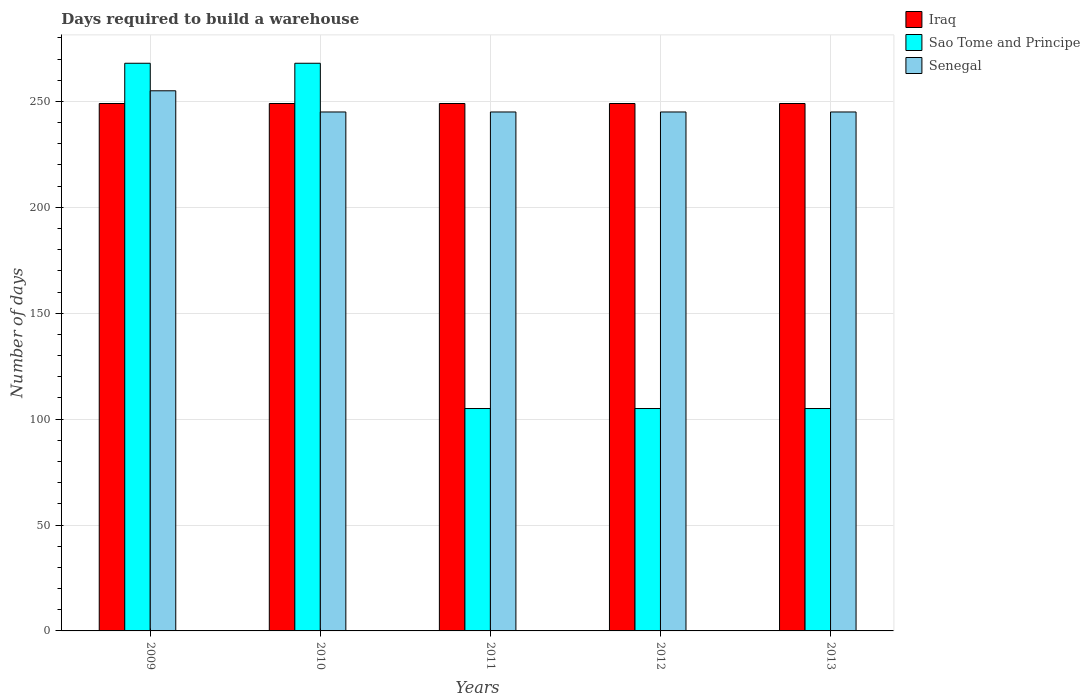How many groups of bars are there?
Provide a short and direct response. 5. Are the number of bars per tick equal to the number of legend labels?
Provide a succinct answer. Yes. How many bars are there on the 3rd tick from the right?
Give a very brief answer. 3. What is the label of the 5th group of bars from the left?
Ensure brevity in your answer.  2013. In how many cases, is the number of bars for a given year not equal to the number of legend labels?
Offer a terse response. 0. What is the days required to build a warehouse in in Iraq in 2009?
Give a very brief answer. 249. Across all years, what is the maximum days required to build a warehouse in in Iraq?
Offer a terse response. 249. Across all years, what is the minimum days required to build a warehouse in in Sao Tome and Principe?
Your answer should be very brief. 105. In which year was the days required to build a warehouse in in Senegal maximum?
Your answer should be compact. 2009. In which year was the days required to build a warehouse in in Senegal minimum?
Keep it short and to the point. 2010. What is the total days required to build a warehouse in in Sao Tome and Principe in the graph?
Offer a very short reply. 851. What is the difference between the days required to build a warehouse in in Senegal in 2009 and that in 2012?
Your answer should be very brief. 10. What is the difference between the days required to build a warehouse in in Sao Tome and Principe in 2011 and the days required to build a warehouse in in Iraq in 2010?
Provide a succinct answer. -144. What is the average days required to build a warehouse in in Iraq per year?
Provide a short and direct response. 249. In the year 2011, what is the difference between the days required to build a warehouse in in Sao Tome and Principe and days required to build a warehouse in in Senegal?
Provide a succinct answer. -140. In how many years, is the days required to build a warehouse in in Senegal greater than 240 days?
Provide a succinct answer. 5. What is the ratio of the days required to build a warehouse in in Sao Tome and Principe in 2010 to that in 2012?
Keep it short and to the point. 2.55. What is the difference between the highest and the second highest days required to build a warehouse in in Iraq?
Offer a terse response. 0. What is the difference between the highest and the lowest days required to build a warehouse in in Iraq?
Your answer should be very brief. 0. What does the 1st bar from the left in 2013 represents?
Provide a succinct answer. Iraq. What does the 2nd bar from the right in 2011 represents?
Keep it short and to the point. Sao Tome and Principe. Is it the case that in every year, the sum of the days required to build a warehouse in in Senegal and days required to build a warehouse in in Sao Tome and Principe is greater than the days required to build a warehouse in in Iraq?
Your answer should be compact. Yes. Are all the bars in the graph horizontal?
Your answer should be very brief. No. How many years are there in the graph?
Your answer should be compact. 5. What is the difference between two consecutive major ticks on the Y-axis?
Provide a short and direct response. 50. Does the graph contain any zero values?
Provide a short and direct response. No. How many legend labels are there?
Your response must be concise. 3. What is the title of the graph?
Offer a very short reply. Days required to build a warehouse. Does "American Samoa" appear as one of the legend labels in the graph?
Make the answer very short. No. What is the label or title of the Y-axis?
Keep it short and to the point. Number of days. What is the Number of days in Iraq in 2009?
Your response must be concise. 249. What is the Number of days in Sao Tome and Principe in 2009?
Give a very brief answer. 268. What is the Number of days in Senegal in 2009?
Make the answer very short. 255. What is the Number of days in Iraq in 2010?
Your response must be concise. 249. What is the Number of days of Sao Tome and Principe in 2010?
Offer a very short reply. 268. What is the Number of days of Senegal in 2010?
Your answer should be compact. 245. What is the Number of days of Iraq in 2011?
Keep it short and to the point. 249. What is the Number of days in Sao Tome and Principe in 2011?
Offer a very short reply. 105. What is the Number of days in Senegal in 2011?
Your answer should be compact. 245. What is the Number of days in Iraq in 2012?
Give a very brief answer. 249. What is the Number of days in Sao Tome and Principe in 2012?
Your answer should be compact. 105. What is the Number of days of Senegal in 2012?
Your response must be concise. 245. What is the Number of days in Iraq in 2013?
Provide a succinct answer. 249. What is the Number of days in Sao Tome and Principe in 2013?
Make the answer very short. 105. What is the Number of days in Senegal in 2013?
Keep it short and to the point. 245. Across all years, what is the maximum Number of days of Iraq?
Make the answer very short. 249. Across all years, what is the maximum Number of days in Sao Tome and Principe?
Provide a short and direct response. 268. Across all years, what is the maximum Number of days of Senegal?
Provide a succinct answer. 255. Across all years, what is the minimum Number of days in Iraq?
Your response must be concise. 249. Across all years, what is the minimum Number of days in Sao Tome and Principe?
Provide a succinct answer. 105. Across all years, what is the minimum Number of days in Senegal?
Your response must be concise. 245. What is the total Number of days of Iraq in the graph?
Ensure brevity in your answer.  1245. What is the total Number of days in Sao Tome and Principe in the graph?
Provide a succinct answer. 851. What is the total Number of days of Senegal in the graph?
Offer a very short reply. 1235. What is the difference between the Number of days of Iraq in 2009 and that in 2010?
Ensure brevity in your answer.  0. What is the difference between the Number of days in Sao Tome and Principe in 2009 and that in 2010?
Keep it short and to the point. 0. What is the difference between the Number of days in Senegal in 2009 and that in 2010?
Provide a short and direct response. 10. What is the difference between the Number of days of Iraq in 2009 and that in 2011?
Keep it short and to the point. 0. What is the difference between the Number of days in Sao Tome and Principe in 2009 and that in 2011?
Offer a terse response. 163. What is the difference between the Number of days of Iraq in 2009 and that in 2012?
Provide a succinct answer. 0. What is the difference between the Number of days of Sao Tome and Principe in 2009 and that in 2012?
Provide a succinct answer. 163. What is the difference between the Number of days of Senegal in 2009 and that in 2012?
Give a very brief answer. 10. What is the difference between the Number of days in Iraq in 2009 and that in 2013?
Provide a succinct answer. 0. What is the difference between the Number of days of Sao Tome and Principe in 2009 and that in 2013?
Offer a very short reply. 163. What is the difference between the Number of days in Senegal in 2009 and that in 2013?
Give a very brief answer. 10. What is the difference between the Number of days of Iraq in 2010 and that in 2011?
Offer a terse response. 0. What is the difference between the Number of days of Sao Tome and Principe in 2010 and that in 2011?
Offer a terse response. 163. What is the difference between the Number of days in Sao Tome and Principe in 2010 and that in 2012?
Make the answer very short. 163. What is the difference between the Number of days of Sao Tome and Principe in 2010 and that in 2013?
Make the answer very short. 163. What is the difference between the Number of days of Senegal in 2010 and that in 2013?
Your answer should be compact. 0. What is the difference between the Number of days in Sao Tome and Principe in 2011 and that in 2012?
Your response must be concise. 0. What is the difference between the Number of days in Iraq in 2011 and that in 2013?
Your answer should be compact. 0. What is the difference between the Number of days of Sao Tome and Principe in 2011 and that in 2013?
Your answer should be very brief. 0. What is the difference between the Number of days of Senegal in 2011 and that in 2013?
Your answer should be compact. 0. What is the difference between the Number of days of Iraq in 2012 and that in 2013?
Offer a very short reply. 0. What is the difference between the Number of days of Senegal in 2012 and that in 2013?
Your response must be concise. 0. What is the difference between the Number of days of Iraq in 2009 and the Number of days of Senegal in 2010?
Offer a terse response. 4. What is the difference between the Number of days in Sao Tome and Principe in 2009 and the Number of days in Senegal in 2010?
Offer a very short reply. 23. What is the difference between the Number of days of Iraq in 2009 and the Number of days of Sao Tome and Principe in 2011?
Provide a succinct answer. 144. What is the difference between the Number of days in Iraq in 2009 and the Number of days in Senegal in 2011?
Provide a succinct answer. 4. What is the difference between the Number of days of Sao Tome and Principe in 2009 and the Number of days of Senegal in 2011?
Ensure brevity in your answer.  23. What is the difference between the Number of days in Iraq in 2009 and the Number of days in Sao Tome and Principe in 2012?
Keep it short and to the point. 144. What is the difference between the Number of days in Iraq in 2009 and the Number of days in Senegal in 2012?
Your response must be concise. 4. What is the difference between the Number of days of Sao Tome and Principe in 2009 and the Number of days of Senegal in 2012?
Offer a very short reply. 23. What is the difference between the Number of days in Iraq in 2009 and the Number of days in Sao Tome and Principe in 2013?
Offer a very short reply. 144. What is the difference between the Number of days in Iraq in 2010 and the Number of days in Sao Tome and Principe in 2011?
Ensure brevity in your answer.  144. What is the difference between the Number of days in Iraq in 2010 and the Number of days in Senegal in 2011?
Make the answer very short. 4. What is the difference between the Number of days of Iraq in 2010 and the Number of days of Sao Tome and Principe in 2012?
Your answer should be very brief. 144. What is the difference between the Number of days of Iraq in 2010 and the Number of days of Sao Tome and Principe in 2013?
Your answer should be very brief. 144. What is the difference between the Number of days in Iraq in 2010 and the Number of days in Senegal in 2013?
Your answer should be compact. 4. What is the difference between the Number of days of Sao Tome and Principe in 2010 and the Number of days of Senegal in 2013?
Make the answer very short. 23. What is the difference between the Number of days of Iraq in 2011 and the Number of days of Sao Tome and Principe in 2012?
Provide a succinct answer. 144. What is the difference between the Number of days of Iraq in 2011 and the Number of days of Senegal in 2012?
Provide a short and direct response. 4. What is the difference between the Number of days of Sao Tome and Principe in 2011 and the Number of days of Senegal in 2012?
Ensure brevity in your answer.  -140. What is the difference between the Number of days in Iraq in 2011 and the Number of days in Sao Tome and Principe in 2013?
Offer a terse response. 144. What is the difference between the Number of days of Iraq in 2011 and the Number of days of Senegal in 2013?
Your answer should be compact. 4. What is the difference between the Number of days of Sao Tome and Principe in 2011 and the Number of days of Senegal in 2013?
Make the answer very short. -140. What is the difference between the Number of days of Iraq in 2012 and the Number of days of Sao Tome and Principe in 2013?
Your response must be concise. 144. What is the difference between the Number of days in Sao Tome and Principe in 2012 and the Number of days in Senegal in 2013?
Offer a very short reply. -140. What is the average Number of days in Iraq per year?
Your answer should be very brief. 249. What is the average Number of days in Sao Tome and Principe per year?
Keep it short and to the point. 170.2. What is the average Number of days in Senegal per year?
Ensure brevity in your answer.  247. In the year 2009, what is the difference between the Number of days of Iraq and Number of days of Sao Tome and Principe?
Make the answer very short. -19. In the year 2009, what is the difference between the Number of days of Sao Tome and Principe and Number of days of Senegal?
Give a very brief answer. 13. In the year 2010, what is the difference between the Number of days of Iraq and Number of days of Senegal?
Provide a short and direct response. 4. In the year 2010, what is the difference between the Number of days in Sao Tome and Principe and Number of days in Senegal?
Provide a succinct answer. 23. In the year 2011, what is the difference between the Number of days in Iraq and Number of days in Sao Tome and Principe?
Provide a short and direct response. 144. In the year 2011, what is the difference between the Number of days of Iraq and Number of days of Senegal?
Your answer should be compact. 4. In the year 2011, what is the difference between the Number of days of Sao Tome and Principe and Number of days of Senegal?
Your answer should be very brief. -140. In the year 2012, what is the difference between the Number of days in Iraq and Number of days in Sao Tome and Principe?
Offer a very short reply. 144. In the year 2012, what is the difference between the Number of days in Sao Tome and Principe and Number of days in Senegal?
Your response must be concise. -140. In the year 2013, what is the difference between the Number of days in Iraq and Number of days in Sao Tome and Principe?
Give a very brief answer. 144. In the year 2013, what is the difference between the Number of days of Sao Tome and Principe and Number of days of Senegal?
Offer a terse response. -140. What is the ratio of the Number of days in Senegal in 2009 to that in 2010?
Keep it short and to the point. 1.04. What is the ratio of the Number of days in Iraq in 2009 to that in 2011?
Offer a very short reply. 1. What is the ratio of the Number of days in Sao Tome and Principe in 2009 to that in 2011?
Provide a succinct answer. 2.55. What is the ratio of the Number of days in Senegal in 2009 to that in 2011?
Your answer should be very brief. 1.04. What is the ratio of the Number of days of Iraq in 2009 to that in 2012?
Ensure brevity in your answer.  1. What is the ratio of the Number of days of Sao Tome and Principe in 2009 to that in 2012?
Ensure brevity in your answer.  2.55. What is the ratio of the Number of days in Senegal in 2009 to that in 2012?
Provide a succinct answer. 1.04. What is the ratio of the Number of days in Iraq in 2009 to that in 2013?
Ensure brevity in your answer.  1. What is the ratio of the Number of days in Sao Tome and Principe in 2009 to that in 2013?
Offer a terse response. 2.55. What is the ratio of the Number of days in Senegal in 2009 to that in 2013?
Your answer should be compact. 1.04. What is the ratio of the Number of days in Sao Tome and Principe in 2010 to that in 2011?
Offer a very short reply. 2.55. What is the ratio of the Number of days in Senegal in 2010 to that in 2011?
Your answer should be compact. 1. What is the ratio of the Number of days of Sao Tome and Principe in 2010 to that in 2012?
Your response must be concise. 2.55. What is the ratio of the Number of days of Senegal in 2010 to that in 2012?
Give a very brief answer. 1. What is the ratio of the Number of days of Iraq in 2010 to that in 2013?
Ensure brevity in your answer.  1. What is the ratio of the Number of days of Sao Tome and Principe in 2010 to that in 2013?
Provide a succinct answer. 2.55. What is the ratio of the Number of days of Iraq in 2011 to that in 2013?
Your answer should be compact. 1. What is the ratio of the Number of days in Senegal in 2011 to that in 2013?
Provide a short and direct response. 1. What is the ratio of the Number of days in Iraq in 2012 to that in 2013?
Your answer should be very brief. 1. What is the ratio of the Number of days of Sao Tome and Principe in 2012 to that in 2013?
Make the answer very short. 1. What is the ratio of the Number of days in Senegal in 2012 to that in 2013?
Your response must be concise. 1. What is the difference between the highest and the lowest Number of days of Sao Tome and Principe?
Provide a short and direct response. 163. 